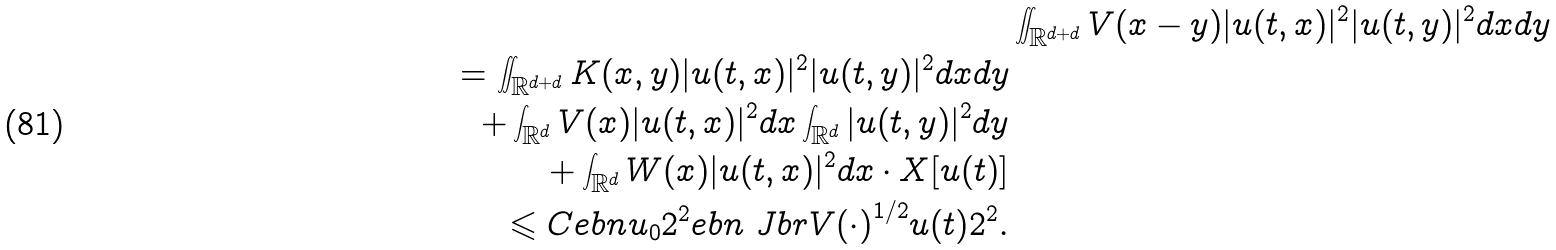<formula> <loc_0><loc_0><loc_500><loc_500>& \iint _ { { \mathbb { R } } ^ { d + d } } V ( x - y ) | u ( t , x ) | ^ { 2 } | u ( t , y ) | ^ { 2 } d x d y \\ = \iint _ { { \mathbb { R } } ^ { d + d } } K ( x , y ) | u ( t , x ) | ^ { 2 } | u ( t , y ) | ^ { 2 } d x d y \\ \quad + \int _ { { \mathbb { R } } ^ { d } } V ( x ) | u ( t , x ) | ^ { 2 } d x \int _ { { \mathbb { R } } ^ { d } } | u ( t , y ) | ^ { 2 } d y \\ \quad + \int _ { { \mathbb { R } } ^ { d } } W ( x ) | u ( t , x ) | ^ { 2 } d x \cdot X [ u ( t ) ] \\ \leqslant C \L e b n { u _ { 0 } } 2 ^ { 2 } \L e b n { \ J b r { V ( \cdot ) } ^ { 1 / 2 } u ( t ) } 2 ^ { 2 } .</formula> 